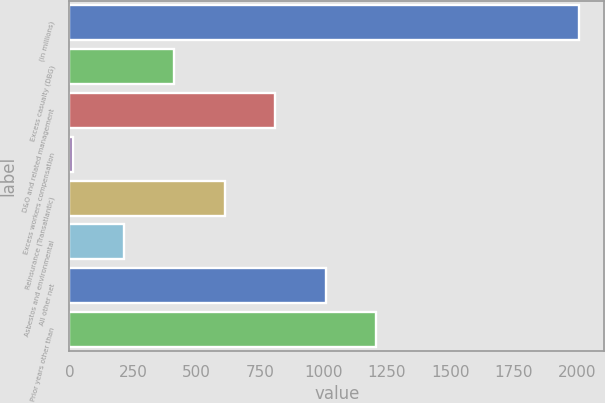Convert chart to OTSL. <chart><loc_0><loc_0><loc_500><loc_500><bar_chart><fcel>(in millions)<fcel>Excess casualty (DBG)<fcel>D&O and related management<fcel>Excess workers compensation<fcel>Reinsurance (Transatlantic)<fcel>Asbestos and environmental<fcel>All other net<fcel>Prior years other than<nl><fcel>2007<fcel>412.6<fcel>811.2<fcel>14<fcel>611.9<fcel>213.3<fcel>1010.5<fcel>1209.8<nl></chart> 